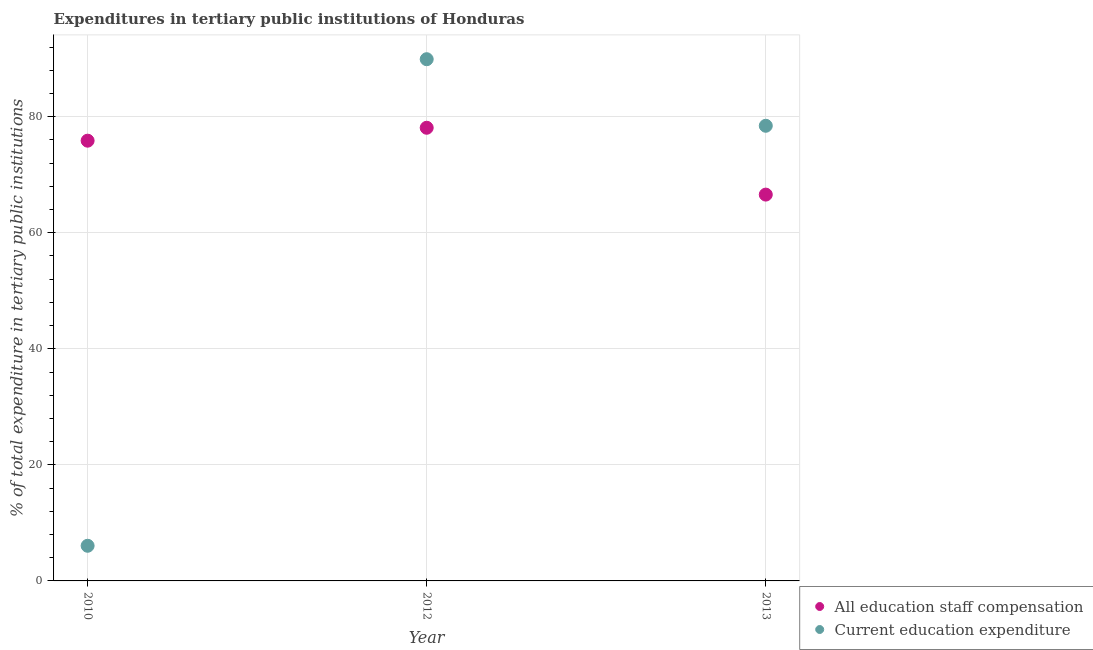How many different coloured dotlines are there?
Ensure brevity in your answer.  2. Is the number of dotlines equal to the number of legend labels?
Keep it short and to the point. Yes. What is the expenditure in staff compensation in 2013?
Your response must be concise. 66.57. Across all years, what is the maximum expenditure in staff compensation?
Provide a succinct answer. 78.09. Across all years, what is the minimum expenditure in staff compensation?
Offer a very short reply. 66.57. In which year was the expenditure in education maximum?
Ensure brevity in your answer.  2012. In which year was the expenditure in education minimum?
Provide a succinct answer. 2010. What is the total expenditure in staff compensation in the graph?
Offer a very short reply. 220.53. What is the difference between the expenditure in staff compensation in 2010 and that in 2013?
Make the answer very short. 9.29. What is the difference between the expenditure in staff compensation in 2010 and the expenditure in education in 2012?
Your response must be concise. -14.04. What is the average expenditure in staff compensation per year?
Offer a terse response. 73.51. In the year 2013, what is the difference between the expenditure in education and expenditure in staff compensation?
Give a very brief answer. 11.86. In how many years, is the expenditure in staff compensation greater than 80 %?
Your answer should be very brief. 0. What is the ratio of the expenditure in education in 2010 to that in 2013?
Ensure brevity in your answer.  0.08. Is the expenditure in education in 2010 less than that in 2012?
Give a very brief answer. Yes. Is the difference between the expenditure in staff compensation in 2012 and 2013 greater than the difference between the expenditure in education in 2012 and 2013?
Give a very brief answer. Yes. What is the difference between the highest and the second highest expenditure in education?
Keep it short and to the point. 11.47. What is the difference between the highest and the lowest expenditure in education?
Ensure brevity in your answer.  83.85. In how many years, is the expenditure in staff compensation greater than the average expenditure in staff compensation taken over all years?
Your answer should be compact. 2. Is the sum of the expenditure in education in 2012 and 2013 greater than the maximum expenditure in staff compensation across all years?
Your answer should be very brief. Yes. Is the expenditure in staff compensation strictly less than the expenditure in education over the years?
Ensure brevity in your answer.  No. How many dotlines are there?
Your answer should be compact. 2. How many years are there in the graph?
Provide a short and direct response. 3. What is the difference between two consecutive major ticks on the Y-axis?
Provide a short and direct response. 20. Are the values on the major ticks of Y-axis written in scientific E-notation?
Provide a short and direct response. No. How are the legend labels stacked?
Offer a very short reply. Vertical. What is the title of the graph?
Give a very brief answer. Expenditures in tertiary public institutions of Honduras. Does "Diarrhea" appear as one of the legend labels in the graph?
Ensure brevity in your answer.  No. What is the label or title of the X-axis?
Give a very brief answer. Year. What is the label or title of the Y-axis?
Offer a very short reply. % of total expenditure in tertiary public institutions. What is the % of total expenditure in tertiary public institutions in All education staff compensation in 2010?
Your answer should be very brief. 75.86. What is the % of total expenditure in tertiary public institutions in Current education expenditure in 2010?
Ensure brevity in your answer.  6.06. What is the % of total expenditure in tertiary public institutions in All education staff compensation in 2012?
Provide a short and direct response. 78.09. What is the % of total expenditure in tertiary public institutions of Current education expenditure in 2012?
Your answer should be compact. 89.9. What is the % of total expenditure in tertiary public institutions of All education staff compensation in 2013?
Your answer should be compact. 66.57. What is the % of total expenditure in tertiary public institutions in Current education expenditure in 2013?
Keep it short and to the point. 78.43. Across all years, what is the maximum % of total expenditure in tertiary public institutions of All education staff compensation?
Provide a short and direct response. 78.09. Across all years, what is the maximum % of total expenditure in tertiary public institutions in Current education expenditure?
Offer a very short reply. 89.9. Across all years, what is the minimum % of total expenditure in tertiary public institutions of All education staff compensation?
Offer a very short reply. 66.57. Across all years, what is the minimum % of total expenditure in tertiary public institutions in Current education expenditure?
Keep it short and to the point. 6.06. What is the total % of total expenditure in tertiary public institutions in All education staff compensation in the graph?
Provide a succinct answer. 220.53. What is the total % of total expenditure in tertiary public institutions of Current education expenditure in the graph?
Provide a short and direct response. 174.39. What is the difference between the % of total expenditure in tertiary public institutions in All education staff compensation in 2010 and that in 2012?
Provide a short and direct response. -2.23. What is the difference between the % of total expenditure in tertiary public institutions of Current education expenditure in 2010 and that in 2012?
Offer a very short reply. -83.85. What is the difference between the % of total expenditure in tertiary public institutions in All education staff compensation in 2010 and that in 2013?
Your response must be concise. 9.29. What is the difference between the % of total expenditure in tertiary public institutions of Current education expenditure in 2010 and that in 2013?
Offer a very short reply. -72.38. What is the difference between the % of total expenditure in tertiary public institutions of All education staff compensation in 2012 and that in 2013?
Provide a short and direct response. 11.52. What is the difference between the % of total expenditure in tertiary public institutions in Current education expenditure in 2012 and that in 2013?
Ensure brevity in your answer.  11.47. What is the difference between the % of total expenditure in tertiary public institutions in All education staff compensation in 2010 and the % of total expenditure in tertiary public institutions in Current education expenditure in 2012?
Your answer should be very brief. -14.04. What is the difference between the % of total expenditure in tertiary public institutions of All education staff compensation in 2010 and the % of total expenditure in tertiary public institutions of Current education expenditure in 2013?
Keep it short and to the point. -2.57. What is the difference between the % of total expenditure in tertiary public institutions of All education staff compensation in 2012 and the % of total expenditure in tertiary public institutions of Current education expenditure in 2013?
Your response must be concise. -0.34. What is the average % of total expenditure in tertiary public institutions of All education staff compensation per year?
Keep it short and to the point. 73.51. What is the average % of total expenditure in tertiary public institutions of Current education expenditure per year?
Provide a short and direct response. 58.13. In the year 2010, what is the difference between the % of total expenditure in tertiary public institutions of All education staff compensation and % of total expenditure in tertiary public institutions of Current education expenditure?
Provide a short and direct response. 69.81. In the year 2012, what is the difference between the % of total expenditure in tertiary public institutions of All education staff compensation and % of total expenditure in tertiary public institutions of Current education expenditure?
Offer a terse response. -11.81. In the year 2013, what is the difference between the % of total expenditure in tertiary public institutions in All education staff compensation and % of total expenditure in tertiary public institutions in Current education expenditure?
Offer a very short reply. -11.86. What is the ratio of the % of total expenditure in tertiary public institutions of All education staff compensation in 2010 to that in 2012?
Your answer should be compact. 0.97. What is the ratio of the % of total expenditure in tertiary public institutions in Current education expenditure in 2010 to that in 2012?
Provide a short and direct response. 0.07. What is the ratio of the % of total expenditure in tertiary public institutions of All education staff compensation in 2010 to that in 2013?
Provide a succinct answer. 1.14. What is the ratio of the % of total expenditure in tertiary public institutions in Current education expenditure in 2010 to that in 2013?
Your answer should be compact. 0.08. What is the ratio of the % of total expenditure in tertiary public institutions of All education staff compensation in 2012 to that in 2013?
Ensure brevity in your answer.  1.17. What is the ratio of the % of total expenditure in tertiary public institutions of Current education expenditure in 2012 to that in 2013?
Your response must be concise. 1.15. What is the difference between the highest and the second highest % of total expenditure in tertiary public institutions of All education staff compensation?
Provide a short and direct response. 2.23. What is the difference between the highest and the second highest % of total expenditure in tertiary public institutions of Current education expenditure?
Your answer should be very brief. 11.47. What is the difference between the highest and the lowest % of total expenditure in tertiary public institutions of All education staff compensation?
Offer a terse response. 11.52. What is the difference between the highest and the lowest % of total expenditure in tertiary public institutions in Current education expenditure?
Provide a succinct answer. 83.85. 